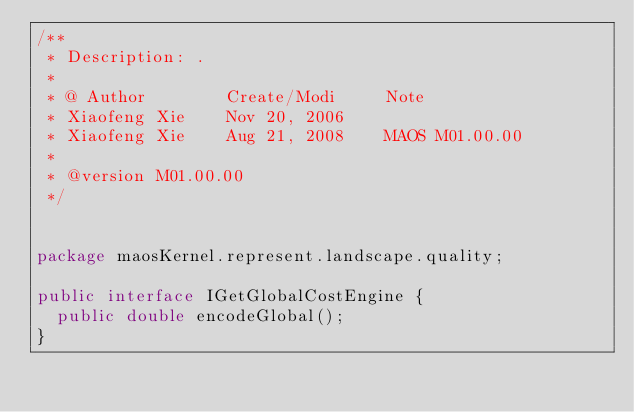Convert code to text. <code><loc_0><loc_0><loc_500><loc_500><_Java_>/**
 * Description: .
 *
 * @ Author        Create/Modi     Note
 * Xiaofeng Xie    Nov 20, 2006
 * Xiaofeng Xie    Aug 21, 2008    MAOS M01.00.00
 *
 * @version M01.00.00
 */


package maosKernel.represent.landscape.quality;

public interface IGetGlobalCostEngine {
  public double encodeGlobal();
}
</code> 